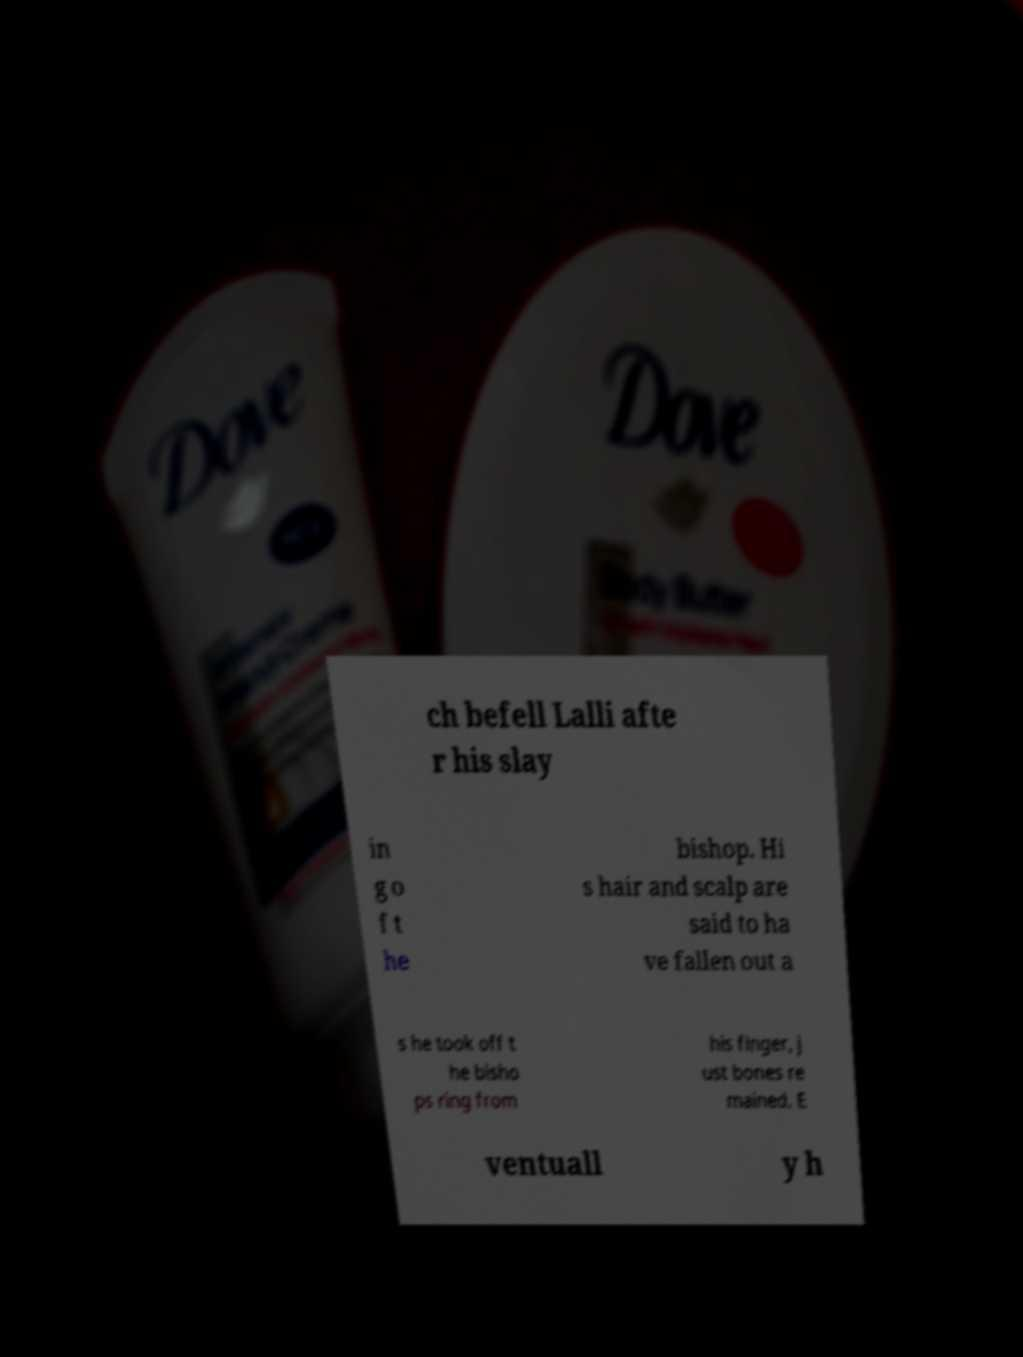Please read and relay the text visible in this image. What does it say? ch befell Lalli afte r his slay in g o f t he bishop. Hi s hair and scalp are said to ha ve fallen out a s he took off t he bisho ps ring from his finger, j ust bones re mained. E ventuall y h 